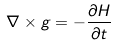Convert formula to latex. <formula><loc_0><loc_0><loc_500><loc_500>\nabla \times g = - { \frac { \partial H } { \partial t } } \,</formula> 